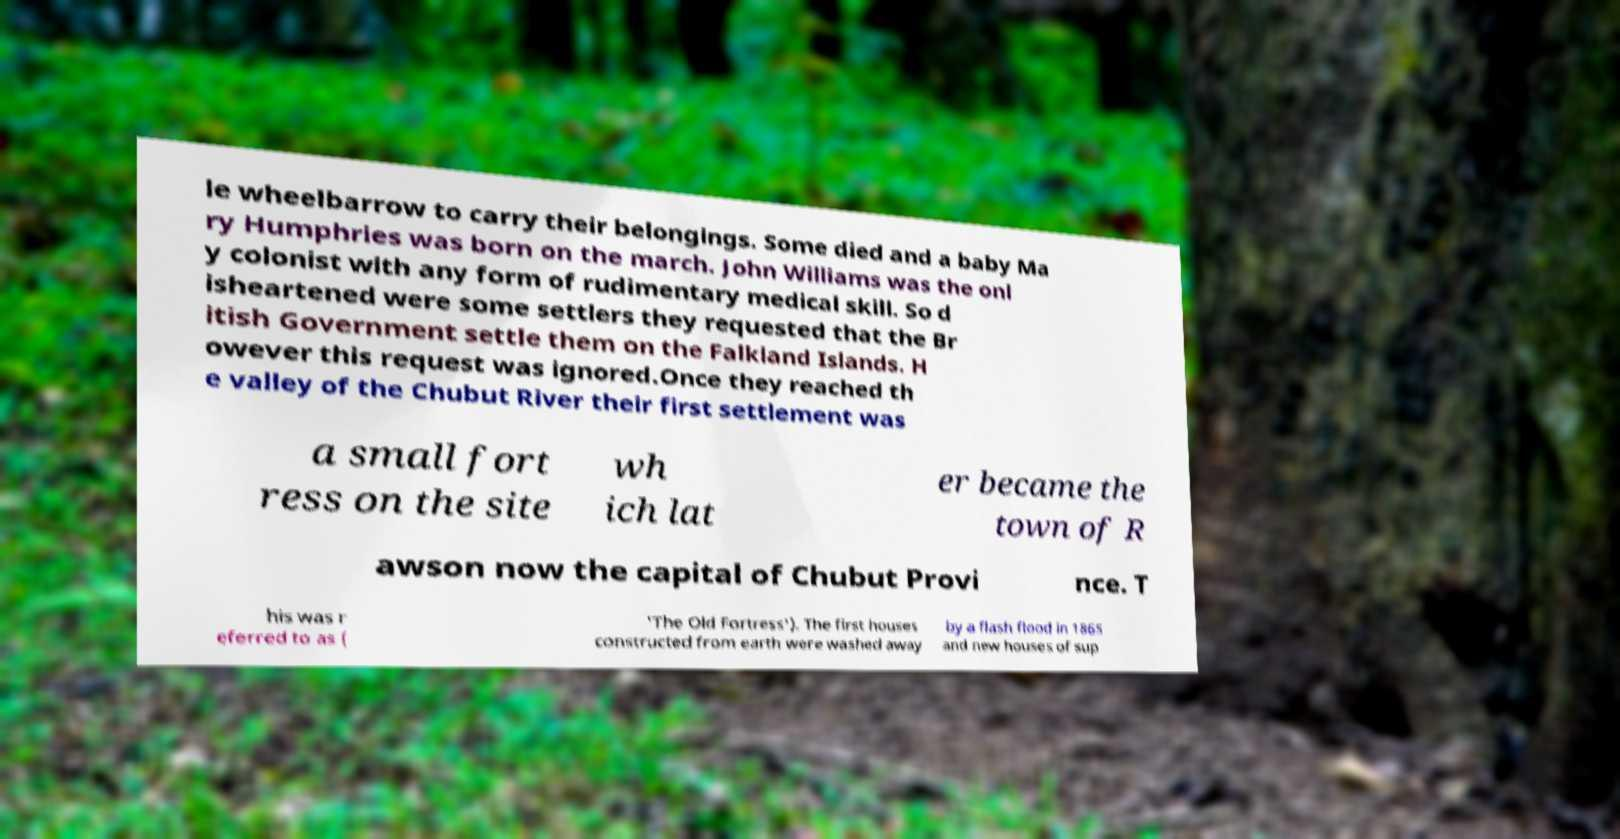There's text embedded in this image that I need extracted. Can you transcribe it verbatim? le wheelbarrow to carry their belongings. Some died and a baby Ma ry Humphries was born on the march. John Williams was the onl y colonist with any form of rudimentary medical skill. So d isheartened were some settlers they requested that the Br itish Government settle them on the Falkland Islands. H owever this request was ignored.Once they reached th e valley of the Chubut River their first settlement was a small fort ress on the site wh ich lat er became the town of R awson now the capital of Chubut Provi nce. T his was r eferred to as ( 'The Old Fortress'). The first houses constructed from earth were washed away by a flash flood in 1865 and new houses of sup 